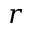Convert formula to latex. <formula><loc_0><loc_0><loc_500><loc_500>r</formula> 